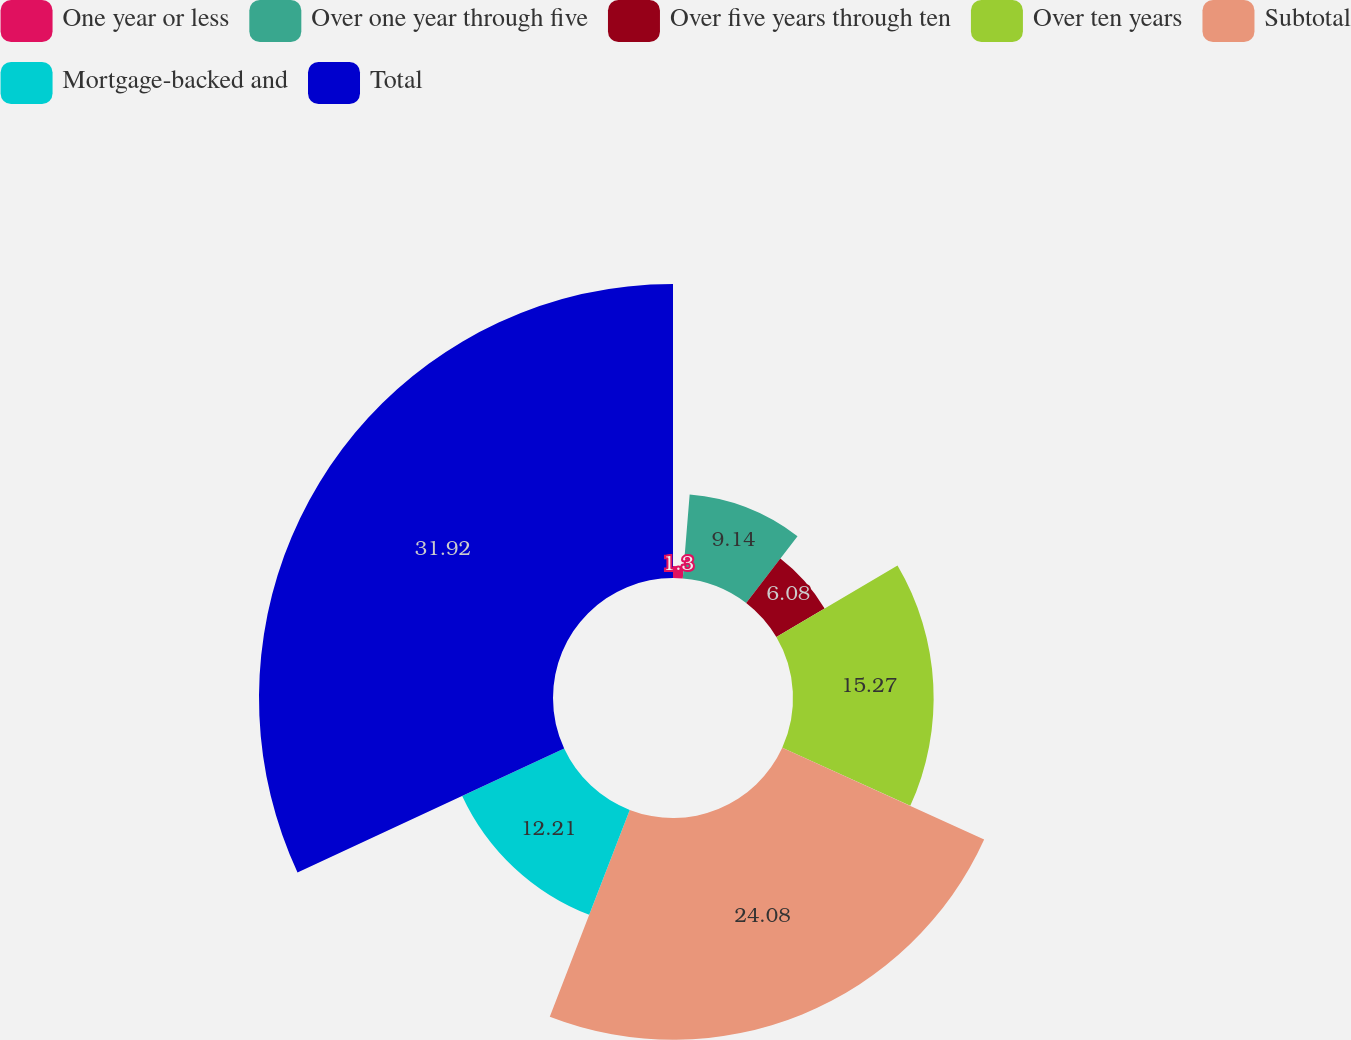Convert chart. <chart><loc_0><loc_0><loc_500><loc_500><pie_chart><fcel>One year or less<fcel>Over one year through five<fcel>Over five years through ten<fcel>Over ten years<fcel>Subtotal<fcel>Mortgage-backed and<fcel>Total<nl><fcel>1.3%<fcel>9.14%<fcel>6.08%<fcel>15.27%<fcel>24.08%<fcel>12.21%<fcel>31.92%<nl></chart> 